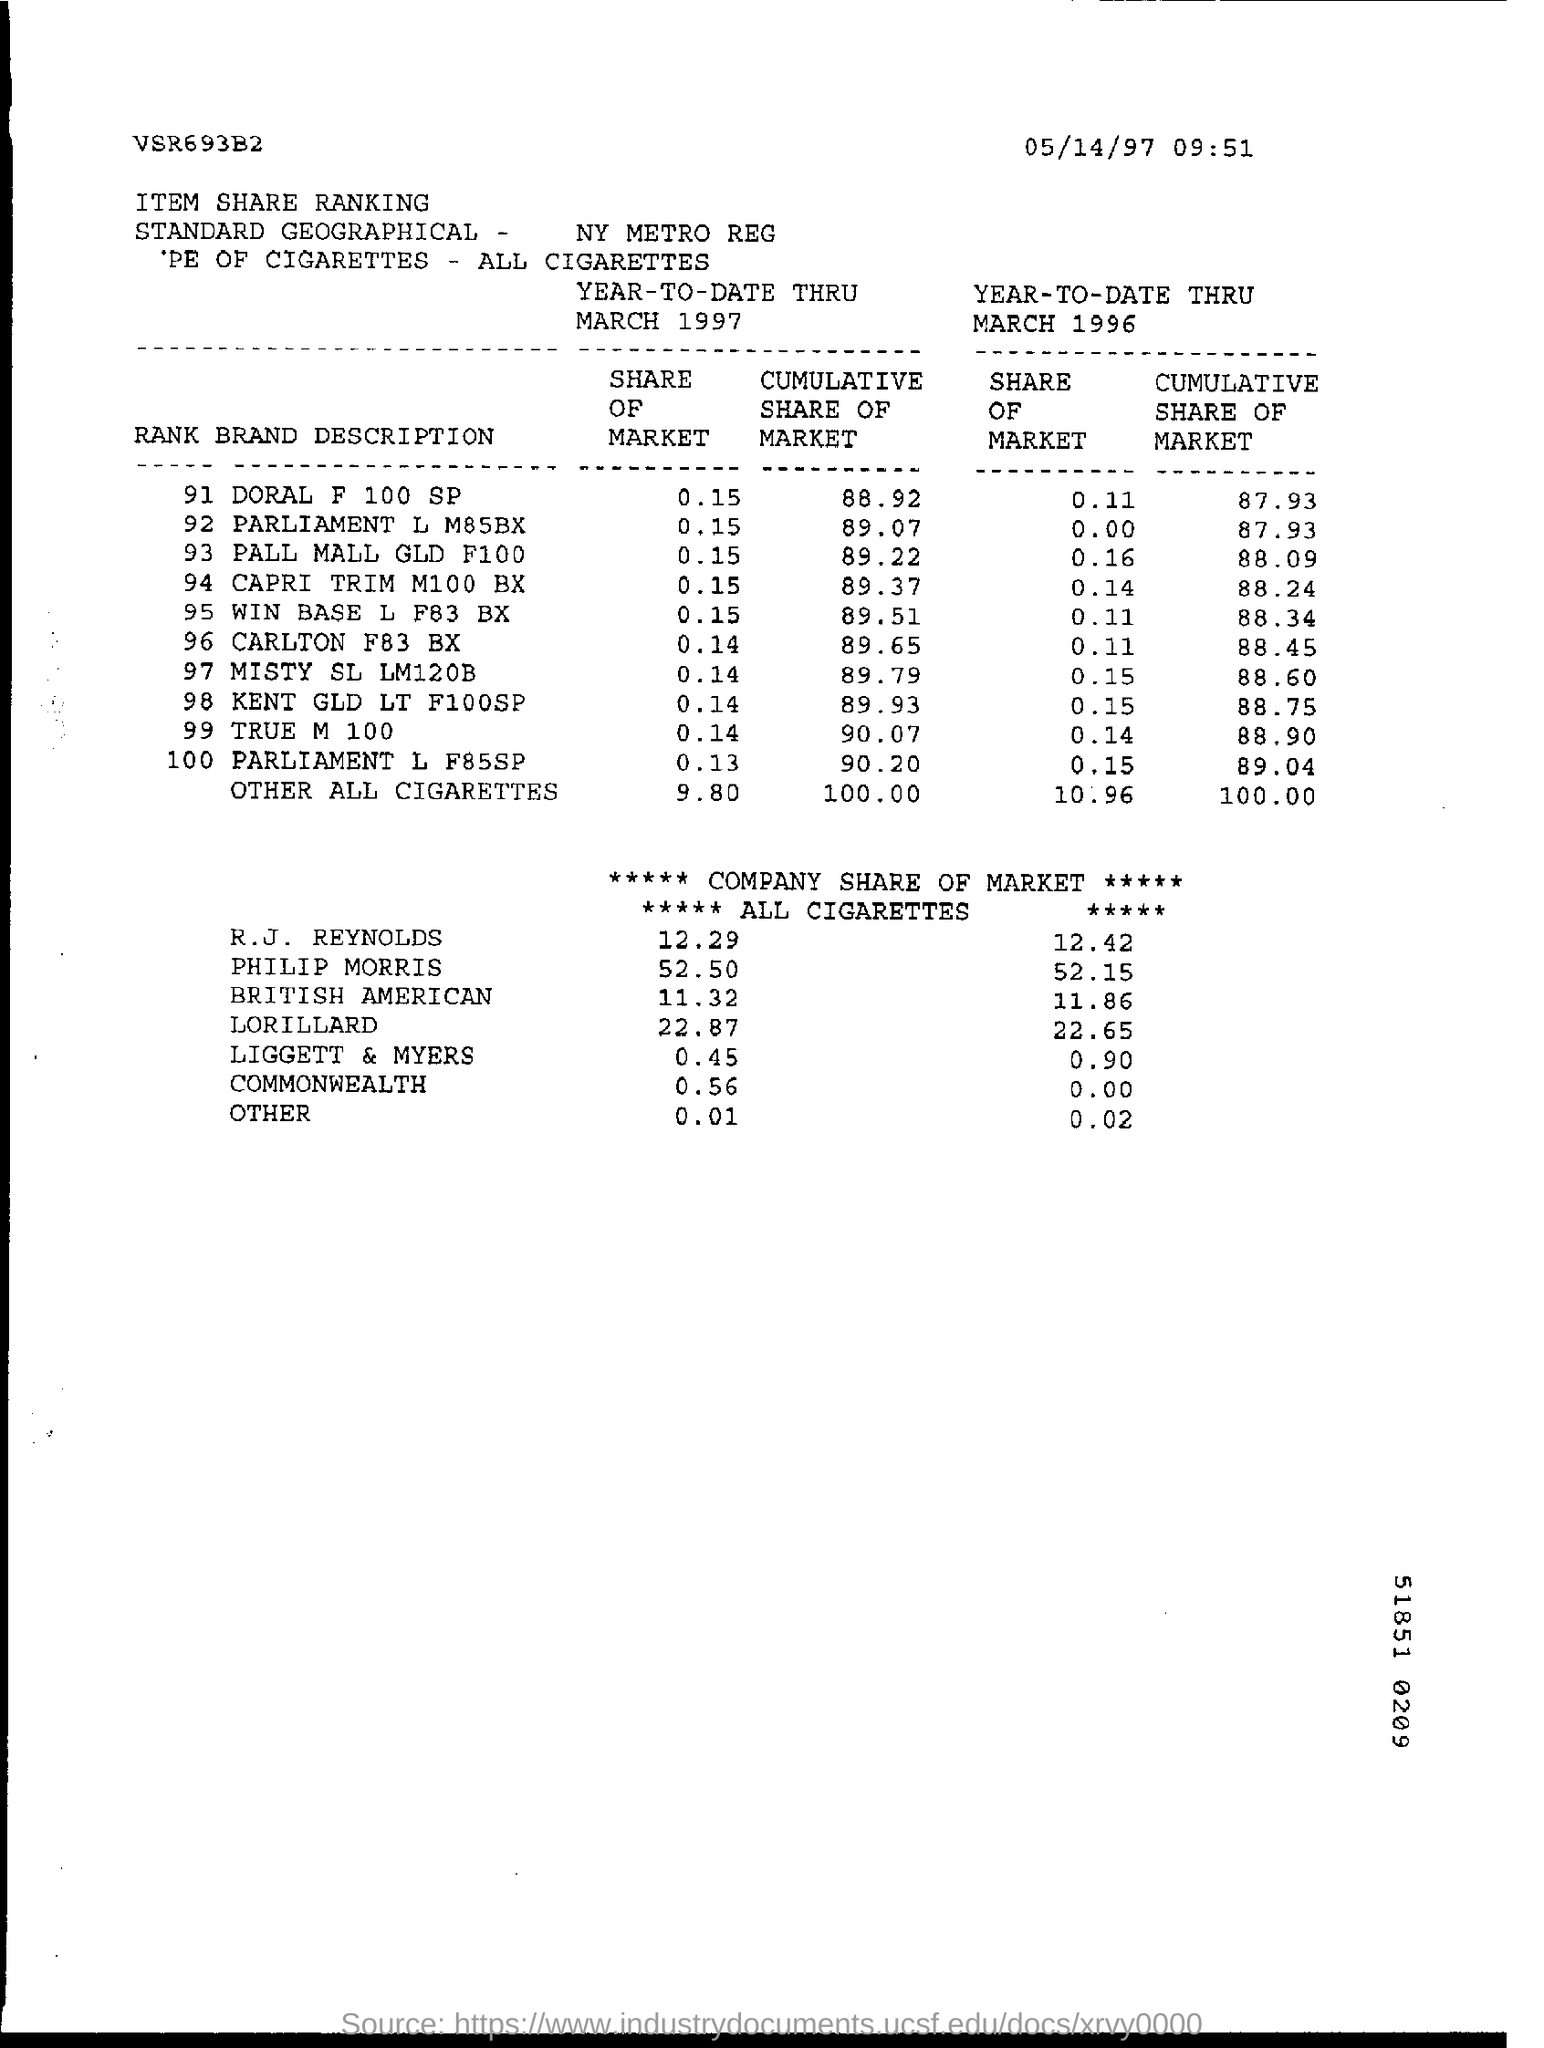How is the market share value of Phillip Morris company in 1997?
Make the answer very short. 52.50. In the year 1996, which company has more share of market?
Your answer should be compact. PHILIP MORRIS. Which company has lowest market share in the year 1997?
Your answer should be compact. LIGGETT & MYERS. Which company has no market shares in the year 1996
Give a very brief answer. COMMONWEALTH. 